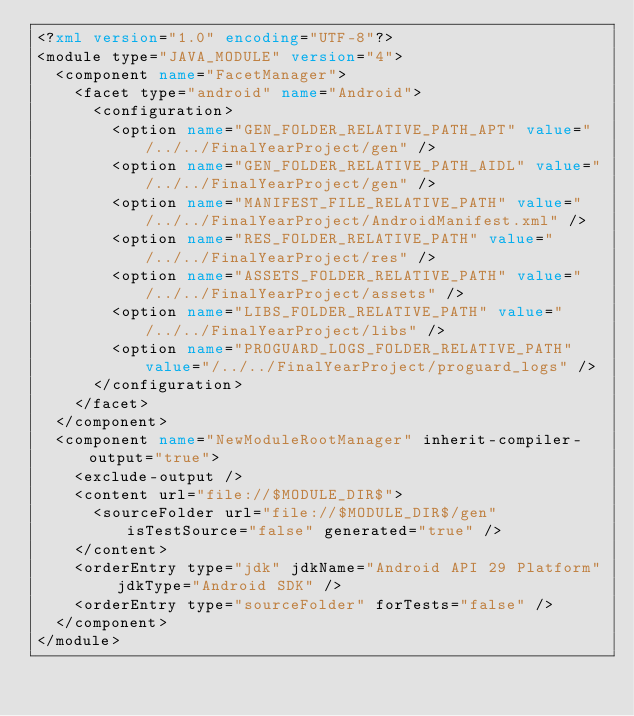Convert code to text. <code><loc_0><loc_0><loc_500><loc_500><_XML_><?xml version="1.0" encoding="UTF-8"?>
<module type="JAVA_MODULE" version="4">
  <component name="FacetManager">
    <facet type="android" name="Android">
      <configuration>
        <option name="GEN_FOLDER_RELATIVE_PATH_APT" value="/../../FinalYearProject/gen" />
        <option name="GEN_FOLDER_RELATIVE_PATH_AIDL" value="/../../FinalYearProject/gen" />
        <option name="MANIFEST_FILE_RELATIVE_PATH" value="/../../FinalYearProject/AndroidManifest.xml" />
        <option name="RES_FOLDER_RELATIVE_PATH" value="/../../FinalYearProject/res" />
        <option name="ASSETS_FOLDER_RELATIVE_PATH" value="/../../FinalYearProject/assets" />
        <option name="LIBS_FOLDER_RELATIVE_PATH" value="/../../FinalYearProject/libs" />
        <option name="PROGUARD_LOGS_FOLDER_RELATIVE_PATH" value="/../../FinalYearProject/proguard_logs" />
      </configuration>
    </facet>
  </component>
  <component name="NewModuleRootManager" inherit-compiler-output="true">
    <exclude-output />
    <content url="file://$MODULE_DIR$">
      <sourceFolder url="file://$MODULE_DIR$/gen" isTestSource="false" generated="true" />
    </content>
    <orderEntry type="jdk" jdkName="Android API 29 Platform" jdkType="Android SDK" />
    <orderEntry type="sourceFolder" forTests="false" />
  </component>
</module></code> 